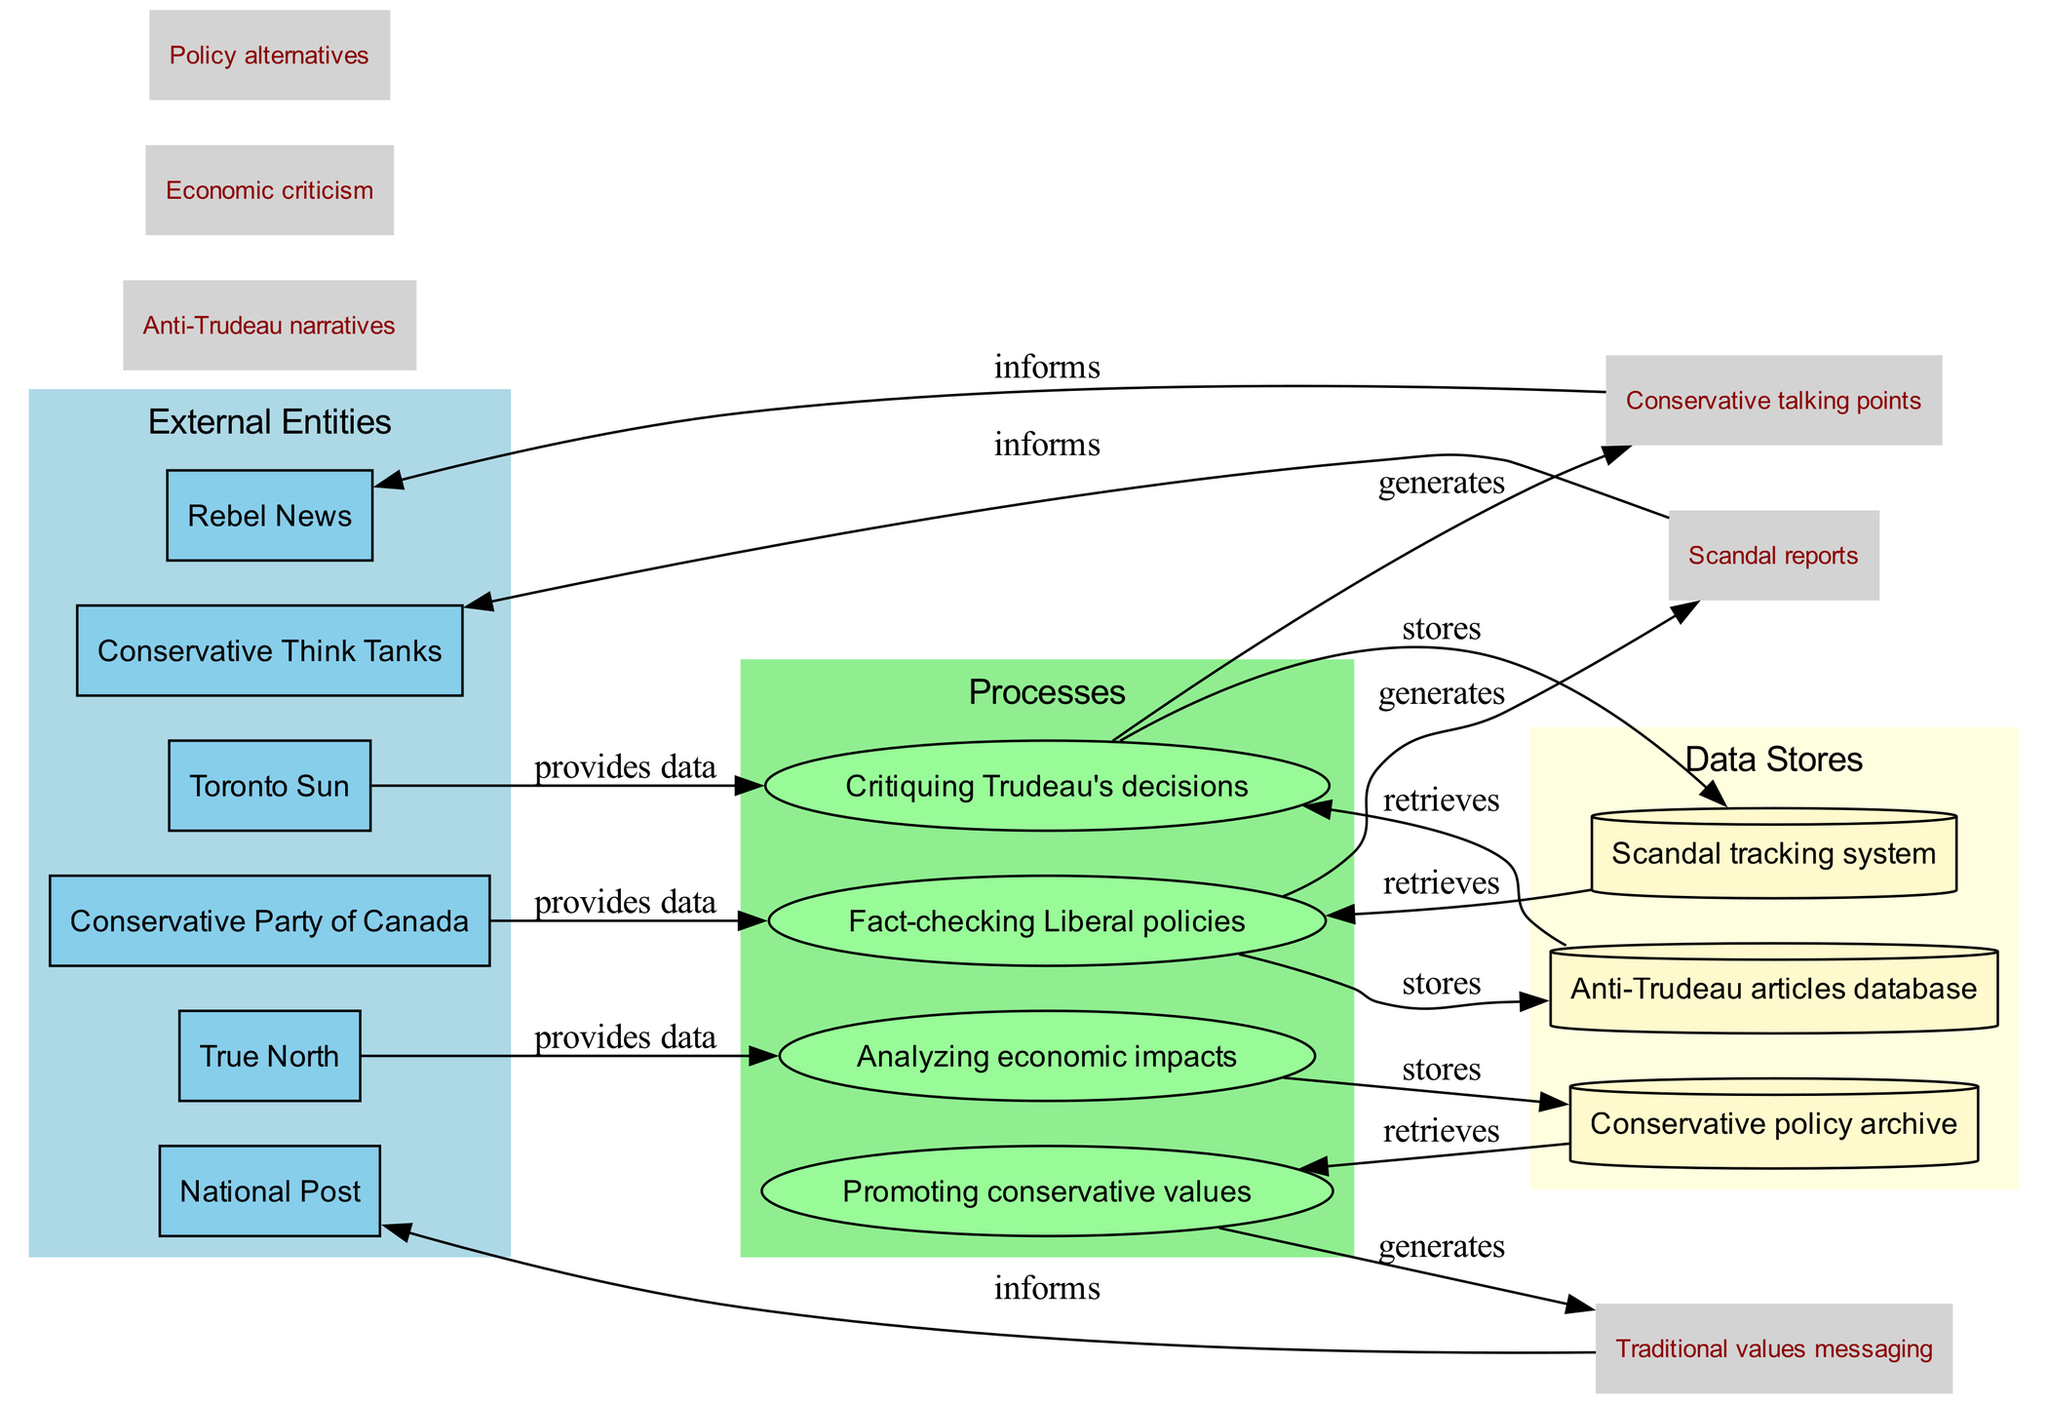What are the external entities depicted in the diagram? The diagram lists several external entities involved in the conservative media information flow in Canada. These include the Conservative Party of Canada, Rebel News, True North, National Post, Toronto Sun, and Conservative Think Tanks.
Answer: Conservative Party of Canada, Rebel News, True North, National Post, Toronto Sun, Conservative Think Tanks How many processes are represented in the diagram? There are four distinct processes identified in the diagram, which are Fact-checking Liberal policies, Critiquing Trudeau's decisions, Analyzing economic impacts, and Promoting conservative values.
Answer: 4 Which external entity provides data for critiquing Trudeau's decisions? The external entity that provides data for Critiquing Trudeau's decisions is the Conservative Party of Canada. The edge connects the Conservative Party of Canada to the process of Critiquing Trudeau's decisions.
Answer: Conservative Party of Canada How many data stores are there in the diagram? The diagram shows three data stores: Anti-Trudeau articles database, Conservative policy archive, and Scandal tracking system.
Answer: 3 What type of messaging is generated from the process of promoting conservative values? The process of Promoting conservative values generates Traditional values messaging, which flows towards the National Post. This is indicated by the directed edge connecting the process to the flow labeled Traditional values messaging.
Answer: Traditional values messaging Which data flows connect the data stores to the processes? The diagram details several connections: the data from the Anti-Trudeau articles database feeds into Fact-checking Liberal policies, the Conservative policy archive connects to Promoting conservative values, and the Scandal tracking system links back to Fact-checking Liberal policies. This shows an interconnected flow of information.
Answer: Anti-Trudeau articles database, Conservative policy archive, Scandal tracking system What is the purpose of the scandal tracking system? The Scandal tracking system serves to store and retrieve data, thus aiding in Fact-checking Liberal policies. It helps to keep track of scandals related to Liberal policies for better critique and analysis.
Answer: Store and retrieve data From which external entity do True North and Rebel News inform? True North and Rebel News are informed by the outputs generated from the process of Fact-checking Liberal policies and Analyzing economic impacts, respectively. The connections drawn in the diagram show the flow of information towards these external entities.
Answer: True North, Rebel News 